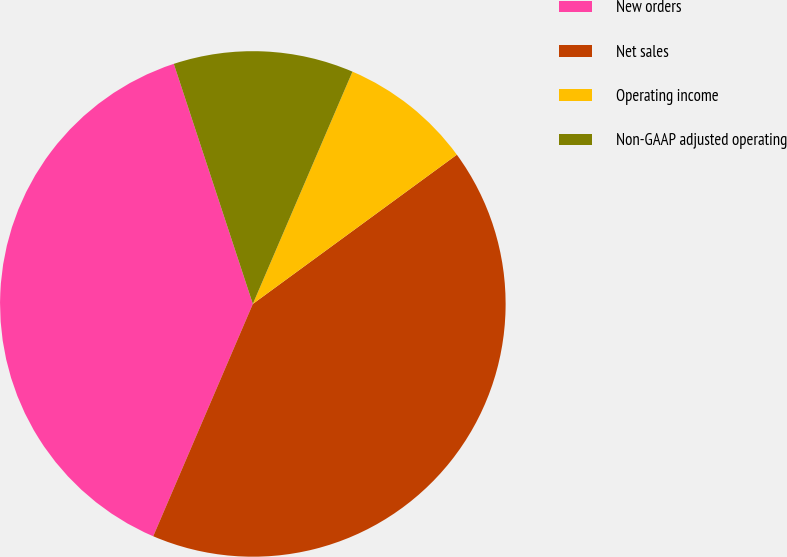<chart> <loc_0><loc_0><loc_500><loc_500><pie_chart><fcel>New orders<fcel>Net sales<fcel>Operating income<fcel>Non-GAAP adjusted operating<nl><fcel>38.49%<fcel>41.5%<fcel>8.5%<fcel>11.51%<nl></chart> 